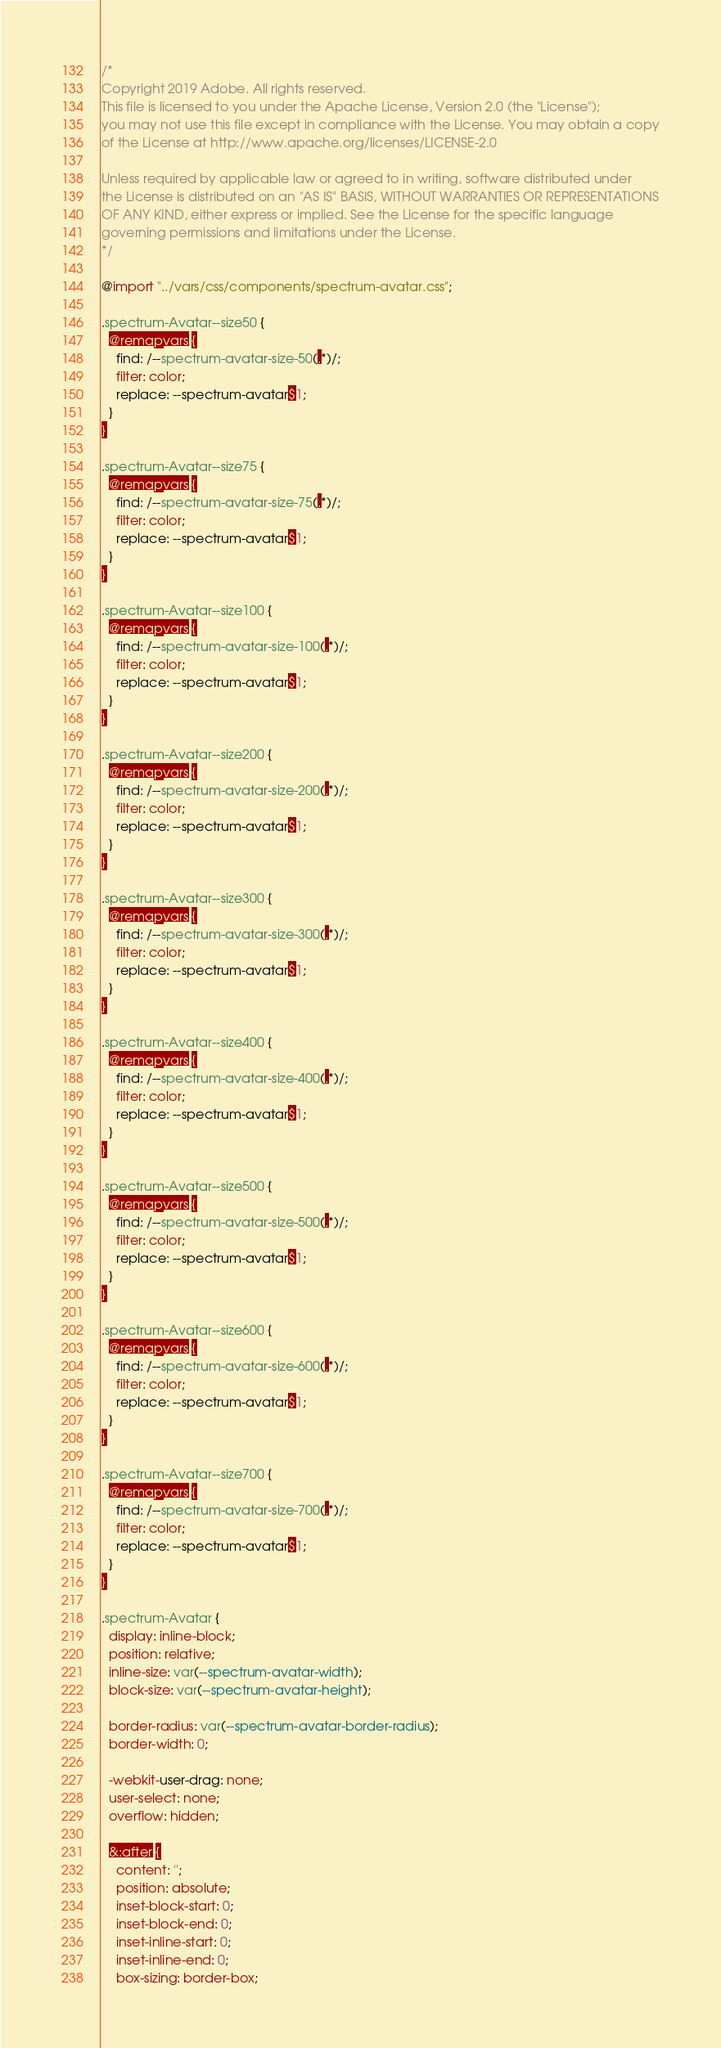<code> <loc_0><loc_0><loc_500><loc_500><_CSS_>/*
Copyright 2019 Adobe. All rights reserved.
This file is licensed to you under the Apache License, Version 2.0 (the "License");
you may not use this file except in compliance with the License. You may obtain a copy
of the License at http://www.apache.org/licenses/LICENSE-2.0

Unless required by applicable law or agreed to in writing, software distributed under
the License is distributed on an "AS IS" BASIS, WITHOUT WARRANTIES OR REPRESENTATIONS
OF ANY KIND, either express or implied. See the License for the specific language
governing permissions and limitations under the License.
*/

@import "../vars/css/components/spectrum-avatar.css";

.spectrum-Avatar--size50 {
  @remapvars {
    find: /--spectrum-avatar-size-50(.*)/;
    filter: color;
    replace: --spectrum-avatar$1;
  }
}

.spectrum-Avatar--size75 {
  @remapvars {
    find: /--spectrum-avatar-size-75(.*)/;
    filter: color;
    replace: --spectrum-avatar$1;
  }
}

.spectrum-Avatar--size100 {
  @remapvars {
    find: /--spectrum-avatar-size-100(.*)/;
    filter: color;
    replace: --spectrum-avatar$1;
  }
}

.spectrum-Avatar--size200 {
  @remapvars {
    find: /--spectrum-avatar-size-200(.*)/;
    filter: color;
    replace: --spectrum-avatar$1;
  }
}

.spectrum-Avatar--size300 {
  @remapvars {
    find: /--spectrum-avatar-size-300(.*)/;
    filter: color;
    replace: --spectrum-avatar$1;
  }
}

.spectrum-Avatar--size400 {
  @remapvars {
    find: /--spectrum-avatar-size-400(.*)/;
    filter: color;
    replace: --spectrum-avatar$1;
  }
}

.spectrum-Avatar--size500 {
  @remapvars {
    find: /--spectrum-avatar-size-500(.*)/;
    filter: color;
    replace: --spectrum-avatar$1;
  }
}

.spectrum-Avatar--size600 {
  @remapvars {
    find: /--spectrum-avatar-size-600(.*)/;
    filter: color;
    replace: --spectrum-avatar$1;
  }
}

.spectrum-Avatar--size700 {
  @remapvars {
    find: /--spectrum-avatar-size-700(.*)/;
    filter: color;
    replace: --spectrum-avatar$1;
  }
}

.spectrum-Avatar {
  display: inline-block;
  position: relative;
  inline-size: var(--spectrum-avatar-width);
  block-size: var(--spectrum-avatar-height);

  border-radius: var(--spectrum-avatar-border-radius);
  border-width: 0;

  -webkit-user-drag: none;
  user-select: none;
  overflow: hidden;

  &:after {
    content: '';
    position: absolute;
    inset-block-start: 0;
    inset-block-end: 0;
    inset-inline-start: 0;
    inset-inline-end: 0;
    box-sizing: border-box;</code> 